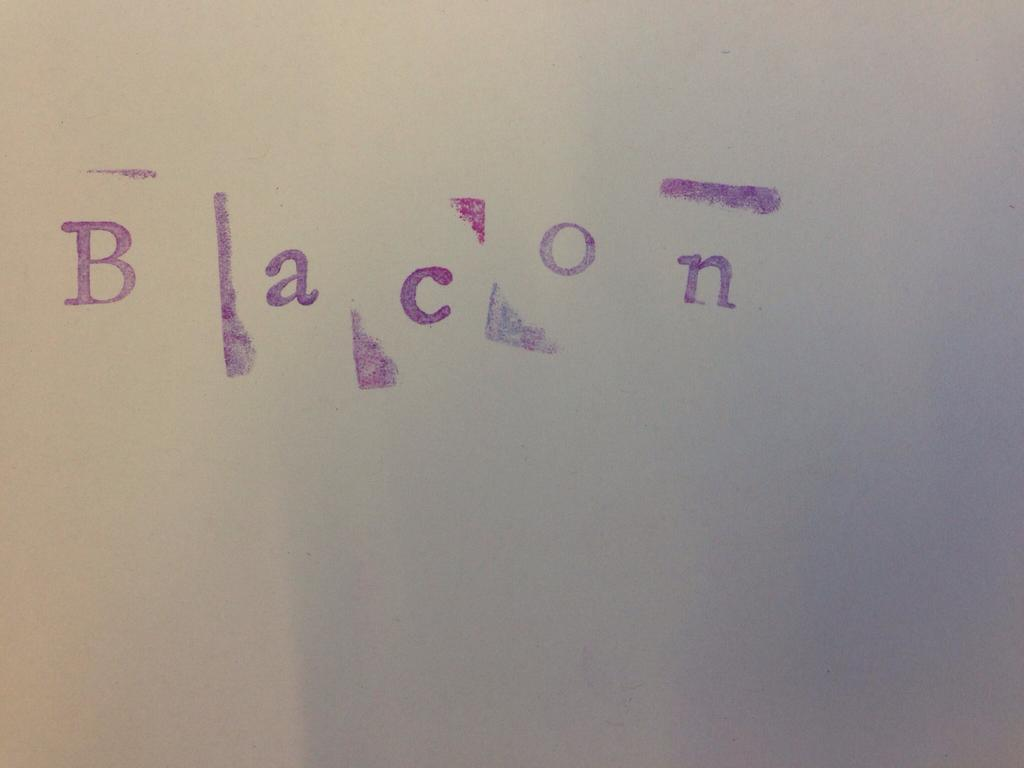<image>
Share a concise interpretation of the image provided. The word bacon is sloppily painted onto a sheet of paper. 